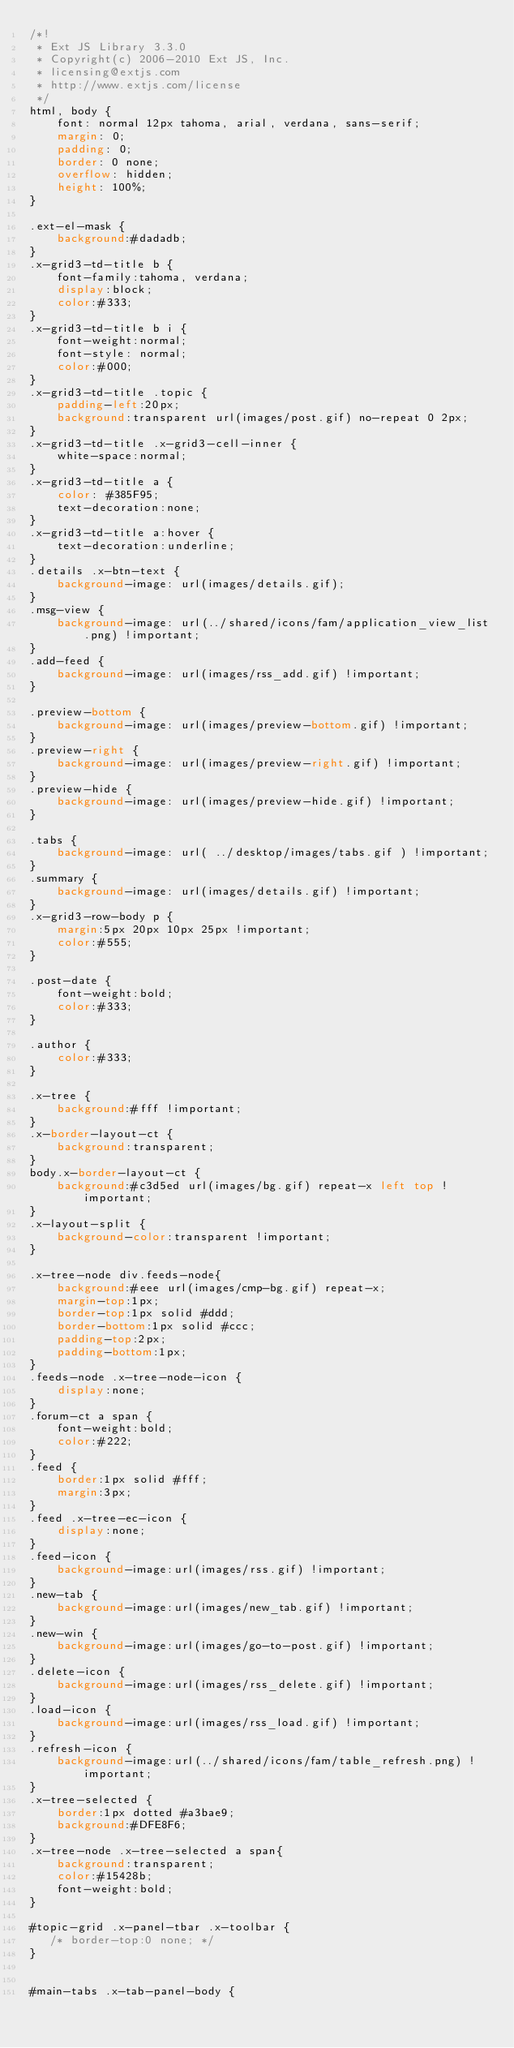<code> <loc_0><loc_0><loc_500><loc_500><_CSS_>/*!
 * Ext JS Library 3.3.0
 * Copyright(c) 2006-2010 Ext JS, Inc.
 * licensing@extjs.com
 * http://www.extjs.com/license
 */
html, body {
	font: normal 12px tahoma, arial, verdana, sans-serif;
	margin: 0;
	padding: 0;
	border: 0 none;
	overflow: hidden;
	height: 100%;
}

.ext-el-mask {
    background:#dadadb;
}
.x-grid3-td-title b {
    font-family:tahoma, verdana;
    display:block;
    color:#333;
}
.x-grid3-td-title b i {
    font-weight:normal;
    font-style: normal;
    color:#000;
}
.x-grid3-td-title .topic {
    padding-left:20px;
    background:transparent url(images/post.gif) no-repeat 0 2px;
}
.x-grid3-td-title .x-grid3-cell-inner {
    white-space:normal;
}
.x-grid3-td-title a {
    color: #385F95;
    text-decoration:none;
}
.x-grid3-td-title a:hover {
    text-decoration:underline;
}
.details .x-btn-text {
    background-image: url(images/details.gif);
}
.msg-view {
    background-image: url(../shared/icons/fam/application_view_list.png) !important;
}
.add-feed {
    background-image: url(images/rss_add.gif) !important;
}

.preview-bottom {
    background-image: url(images/preview-bottom.gif) !important;
}
.preview-right {
    background-image: url(images/preview-right.gif) !important;
}
.preview-hide {
    background-image: url(images/preview-hide.gif) !important;
}

.tabs {
    background-image: url( ../desktop/images/tabs.gif ) !important;
}
.summary {
    background-image: url(images/details.gif) !important;
}
.x-grid3-row-body p {
    margin:5px 20px 10px 25px !important;
    color:#555;
}

.post-date {
    font-weight:bold;
    color:#333;
}

.author {
    color:#333;
}

.x-tree {
    background:#fff !important;
}
.x-border-layout-ct {
    background:transparent;
}
body.x-border-layout-ct {
    background:#c3d5ed url(images/bg.gif) repeat-x left top !important;
}
.x-layout-split {
    background-color:transparent !important;
}

.x-tree-node div.feeds-node{
    background:#eee url(images/cmp-bg.gif) repeat-x;
    margin-top:1px;
    border-top:1px solid #ddd;
    border-bottom:1px solid #ccc;
    padding-top:2px;
    padding-bottom:1px;
}
.feeds-node .x-tree-node-icon {
    display:none;
}
.forum-ct a span {
    font-weight:bold;
    color:#222;
}
.feed {
    border:1px solid #fff;
    margin:3px;
}
.feed .x-tree-ec-icon {
    display:none;
}
.feed-icon {
    background-image:url(images/rss.gif) !important;
}
.new-tab {
    background-image:url(images/new_tab.gif) !important;
}
.new-win {
    background-image:url(images/go-to-post.gif) !important;
}
.delete-icon {
    background-image:url(images/rss_delete.gif) !important;
}
.load-icon {
    background-image:url(images/rss_load.gif) !important;
}
.refresh-icon {
    background-image:url(../shared/icons/fam/table_refresh.png) !important;
}
.x-tree-selected {
    border:1px dotted #a3bae9;
    background:#DFE8F6;
}
.x-tree-node .x-tree-selected a span{
	background:transparent;
	color:#15428b;
    font-weight:bold;
}

#topic-grid .x-panel-tbar .x-toolbar {
   /* border-top:0 none; */
}


#main-tabs .x-tab-panel-body {</code> 